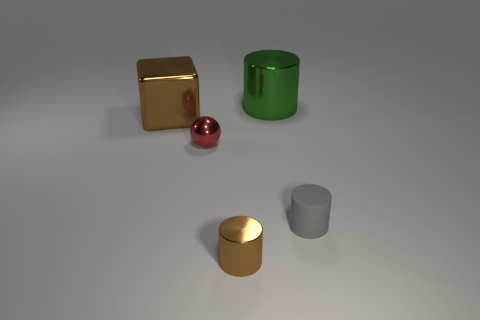Is the color of the large cube the same as the small metallic cylinder?
Offer a very short reply. Yes. There is a green metallic thing that is the same shape as the small brown shiny thing; what size is it?
Your answer should be very brief. Large. Is the color of the large cube the same as the shiny object in front of the tiny sphere?
Make the answer very short. Yes. The metallic object that is the same color as the small metallic cylinder is what size?
Provide a succinct answer. Large. Is there a metallic cylinder that has the same size as the brown block?
Provide a short and direct response. Yes. Do the large green metal thing and the brown thing right of the large brown cube have the same shape?
Offer a terse response. Yes. There is a thing in front of the tiny gray object; is its size the same as the metallic cylinder behind the red thing?
Provide a succinct answer. No. What number of other objects are the same shape as the big green object?
Offer a very short reply. 2. What is the material of the cylinder on the left side of the green cylinder behind the small sphere?
Make the answer very short. Metal. How many metal objects are gray things or tiny yellow blocks?
Provide a short and direct response. 0. 